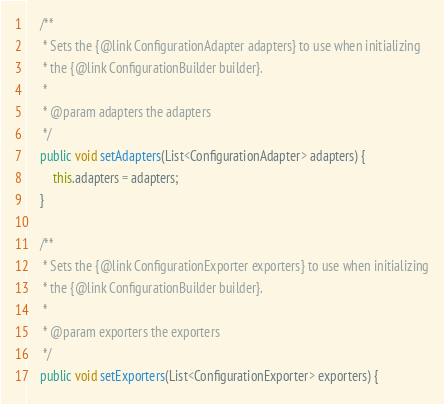<code> <loc_0><loc_0><loc_500><loc_500><_Java_>
    /**
     * Sets the {@link ConfigurationAdapter adapters} to use when initializing
     * the {@link ConfigurationBuilder builder}.
     *
     * @param adapters the adapters
     */
    public void setAdapters(List<ConfigurationAdapter> adapters) {
        this.adapters = adapters;
    }

    /**
     * Sets the {@link ConfigurationExporter exporters} to use when initializing
     * the {@link ConfigurationBuilder builder}.
     *
     * @param exporters the exporters
     */
    public void setExporters(List<ConfigurationExporter> exporters) {</code> 